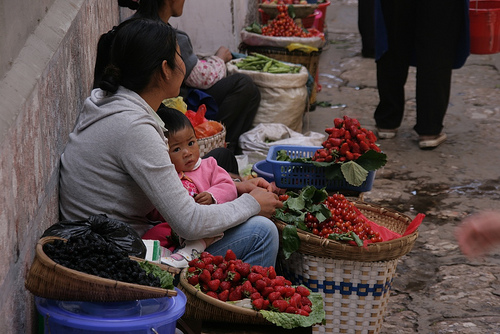<image>
Is there a fruit on the leaf? Yes. Looking at the image, I can see the fruit is positioned on top of the leaf, with the leaf providing support. 